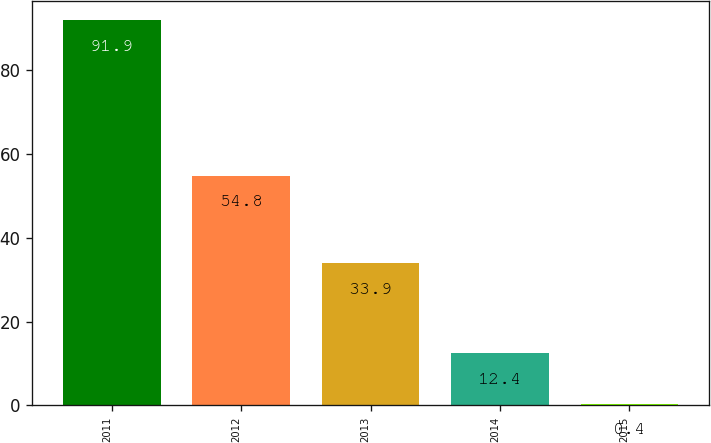<chart> <loc_0><loc_0><loc_500><loc_500><bar_chart><fcel>2011<fcel>2012<fcel>2013<fcel>2014<fcel>2015<nl><fcel>91.9<fcel>54.8<fcel>33.9<fcel>12.4<fcel>0.4<nl></chart> 